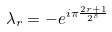Convert formula to latex. <formula><loc_0><loc_0><loc_500><loc_500>\lambda _ { r } = - e ^ { i \pi \frac { 2 r + 1 } { 2 ^ { s } } }</formula> 